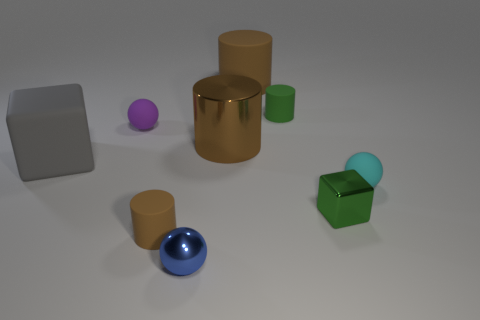Subtract all matte balls. How many balls are left? 1 Subtract all purple spheres. How many spheres are left? 2 Add 1 tiny yellow rubber cylinders. How many objects exist? 10 Subtract all cylinders. How many objects are left? 5 Subtract 2 balls. How many balls are left? 1 Subtract all brown cubes. How many cyan cylinders are left? 0 Subtract 0 cyan cubes. How many objects are left? 9 Subtract all blue spheres. Subtract all cyan cylinders. How many spheres are left? 2 Subtract all small blue shiny balls. Subtract all rubber blocks. How many objects are left? 7 Add 1 big rubber blocks. How many big rubber blocks are left? 2 